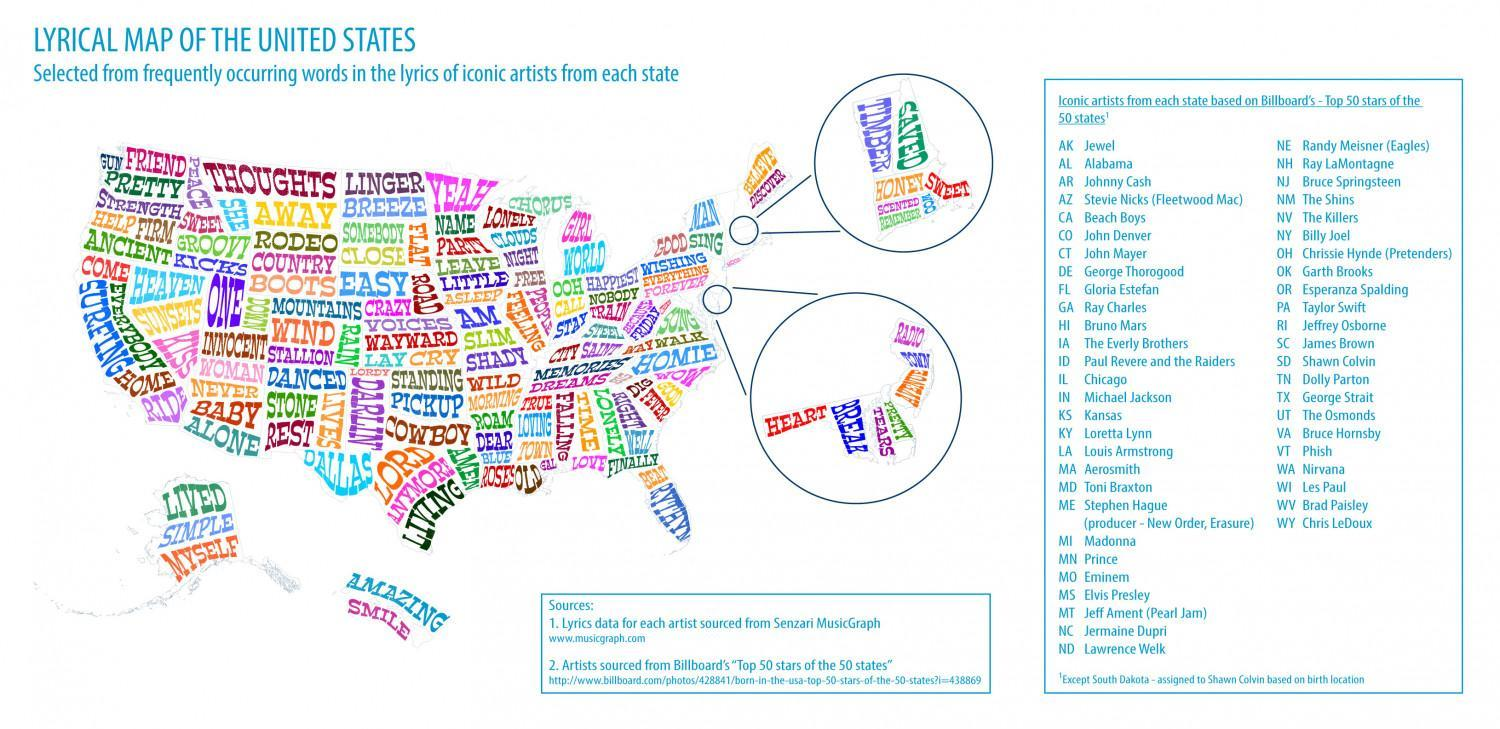Which is the word written in biggest letters?
Answer the question with a short phrase. ONE 